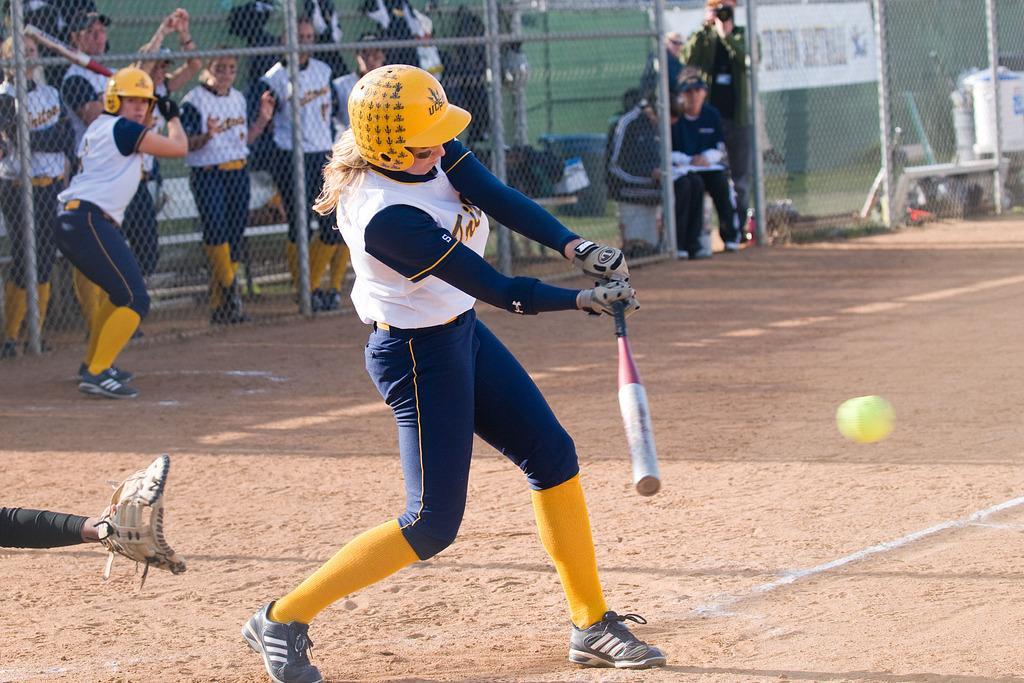Could you give a brief overview of what you see in this image? In the middle of the image a woman wore a helmet and holding a bat. Near the bat ball is in the air. In the background of the image there is a mesh. Through this mess we can see people, hoarding, bench, bat and things.  